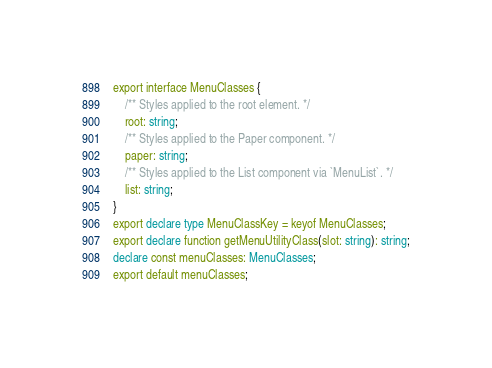<code> <loc_0><loc_0><loc_500><loc_500><_TypeScript_>export interface MenuClasses {
    /** Styles applied to the root element. */
    root: string;
    /** Styles applied to the Paper component. */
    paper: string;
    /** Styles applied to the List component via `MenuList`. */
    list: string;
}
export declare type MenuClassKey = keyof MenuClasses;
export declare function getMenuUtilityClass(slot: string): string;
declare const menuClasses: MenuClasses;
export default menuClasses;
</code> 